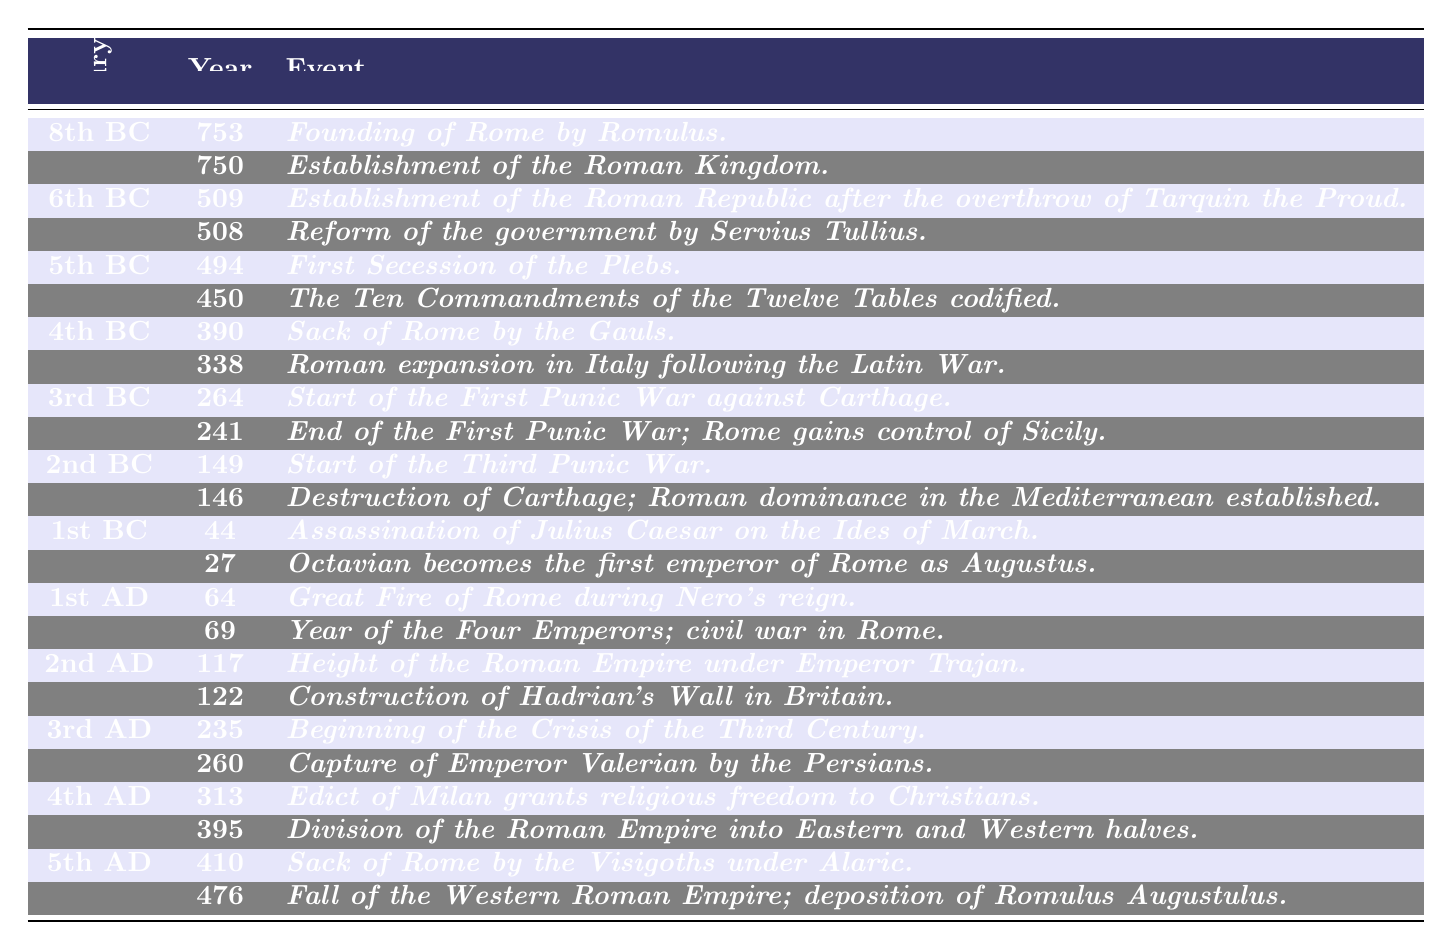What event marked the founding of Rome? According to the table, the founding of Rome occurred in the year 753 BC, when Romulus founded the city.
Answer: Founding of Rome by Romulus What was established in 509 BC? The table indicates that in 509 BC, the Roman Republic was established after the overthrow of Tarquin the Proud.
Answer: Establishment of the Roman Republic How many events are listed for the 3rd Century BC? The table shows that there are 2 events listed for the 3rd Century BC, specifically the start and end of the First Punic War.
Answer: 2 events Which event occurred first, the Sack of Rome by the Gauls or Roman expansion following the Latin War? The table states that the Sack of Rome by the Gauls happened in 390 BC, while Roman expansion occurred in 338 BC, thus the Sack of Rome occurred first.
Answer: Sack of Rome by the Gauls What significant change took place in the Roman Empire in 395 AD? In 395 AD, the table indicates that the Roman Empire was divided into Eastern and Western halves.
Answer: Division of the Roman Empire What event marks the end of the Western Roman Empire? The table mentions that the fall of the Western Roman Empire occurred in 476 AD with the deposition of Romulus Augustulus.
Answer: Fall of the Western Roman Empire How many centuries are represented in the timeline? By reviewing the table, we see events spanning 10 centuries, from the 8th Century BC to the 5th Century AD.
Answer: 10 centuries Which two events from the 1st Century BC are listed? The table lists the assassination of Julius Caesar in 44 BC and Octavian becoming emperor in 27 BC as significant events from the 1st Century BC.
Answer: Assassination of Julius Caesar and Octavian becomes emperor What is the difference in years between the end of the First Punic War and the start of the Second Punic War? The First Punic War ended in 241 BC and the Second Punic War started in 149 BC. Calculating the difference, we find 241 - 149 = 92 years.
Answer: 92 years In what century did the Great Fire of Rome occur and which Emperor was ruling? The Great Fire of Rome occurred in 64 AD, which is in the 1st Century AD, during Nero's reign.
Answer: 1st Century AD, during Nero's reign What event in the 2nd Century AD indicated the height of the Roman Empire? The table specifies that the height of the Roman Empire under Emperor Trajan occurred in 117 AD.
Answer: Height of the Roman Empire under Emperor Trajan 